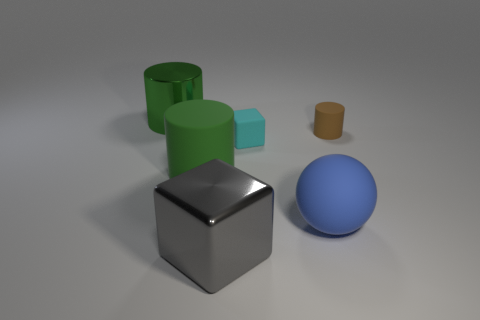Add 2 small green metallic spheres. How many objects exist? 8 Subtract all spheres. How many objects are left? 5 Subtract all large cylinders. Subtract all green rubber objects. How many objects are left? 3 Add 4 small cyan rubber objects. How many small cyan rubber objects are left? 5 Add 4 rubber cylinders. How many rubber cylinders exist? 6 Subtract 1 cyan cubes. How many objects are left? 5 